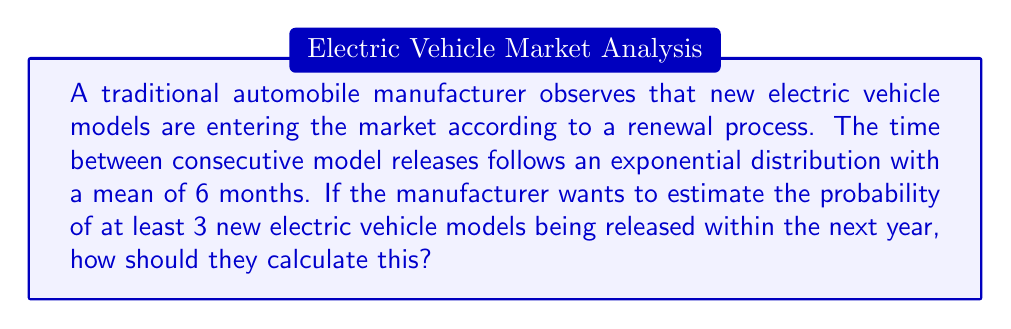Help me with this question. To solve this problem, we need to use the properties of the Poisson process, which is a special case of a renewal process with exponentially distributed inter-arrival times.

Step 1: Identify the rate parameter λ
The mean time between arrivals is 6 months, so λ = 1/6 per month.

Step 2: Calculate the rate for a one-year period
Since we're interested in a one-year period, we need to adjust our rate:
λ_year = λ * 12 = (1/6) * 12 = 2 arrivals per year

Step 3: Use the Poisson distribution
The number of arrivals in a fixed time interval in a Poisson process follows a Poisson distribution. Let X be the number of new EV models in a year.

X ~ Poisson(λ_year = 2)

Step 4: Calculate the probability of at least 3 arrivals
P(X ≥ 3) = 1 - P(X < 3) = 1 - [P(X = 0) + P(X = 1) + P(X = 2)]

Using the Poisson probability mass function:
P(X = k) = (e^(-λ) * λ^k) / k!

P(X = 0) = e^(-2) * (2^0) / 0! = e^(-2)
P(X = 1) = e^(-2) * (2^1) / 1! = 2e^(-2)
P(X = 2) = e^(-2) * (2^2) / 2! = 2e^(-2)

Therefore,
P(X ≥ 3) = 1 - [e^(-2) + 2e^(-2) + 2e^(-2)]
          = 1 - [e^(-2)(1 + 2 + 2)]
          = 1 - 5e^(-2)
          ≈ 0.3233
Answer: $1 - 5e^{-2}$ or approximately 0.3233 